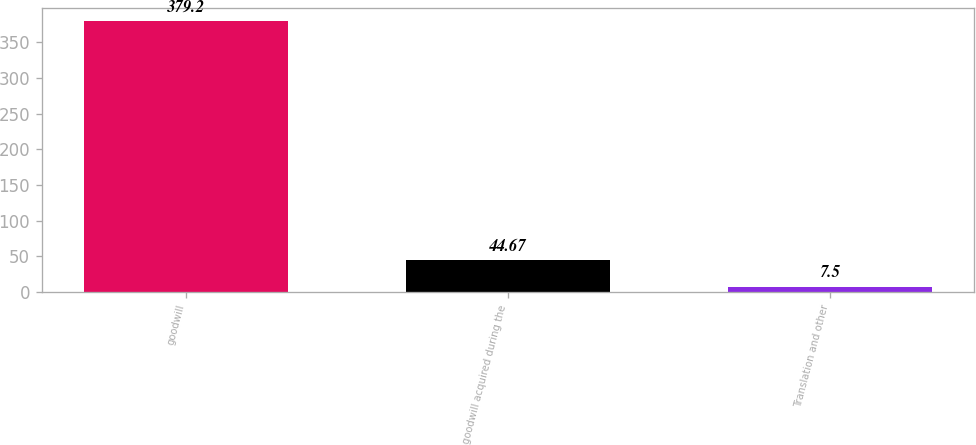Convert chart. <chart><loc_0><loc_0><loc_500><loc_500><bar_chart><fcel>goodwill<fcel>goodwill acquired during the<fcel>Translation and other<nl><fcel>379.2<fcel>44.67<fcel>7.5<nl></chart> 